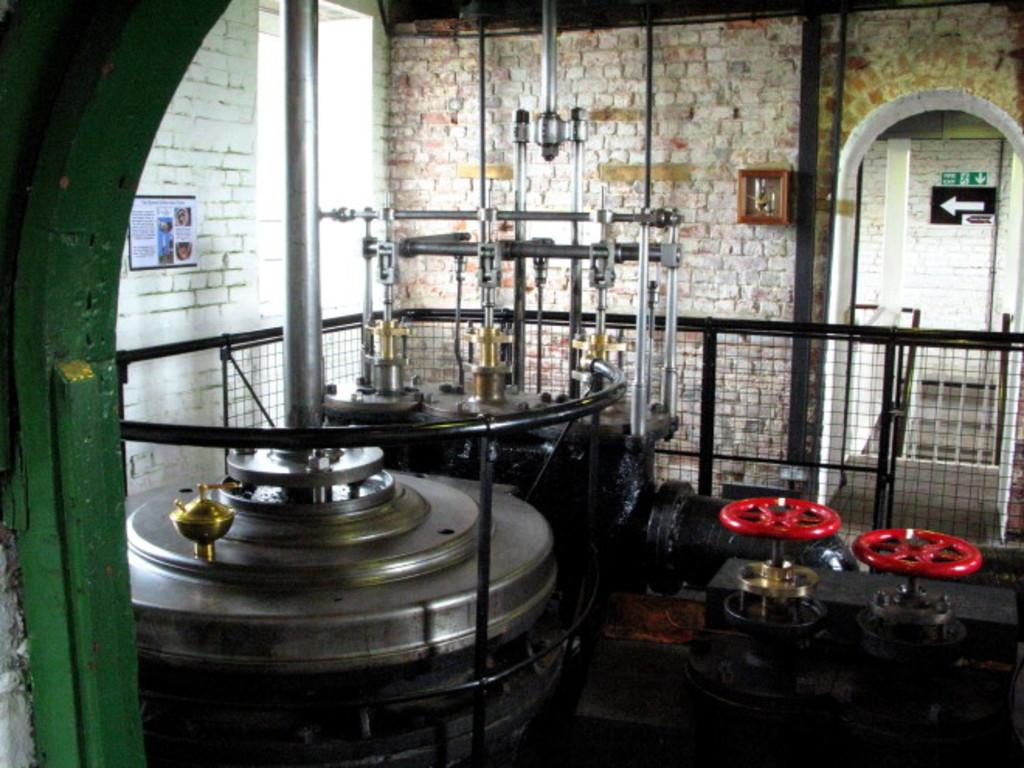What type of objects with metal poles and wheels can be seen in the image? There are machines with metal poles and wheels in the image. What is the paper used for in the image? The purpose of the paper in the image is not specified, but it is present. Where is the wooden box located in the image? The wooden box is on a wall in the image. What type of barrier is present in the image? There is a metal fence in the image. What type of information might be conveyed by the sign boards in the image? The sign boards in the image might convey information such as directions, warnings, or advertisements. What type of coast can be seen in the image? There is no coast present in the image; it features machines, a wooden box, a metal fence, and sign boards. How much heat is being generated by the machines in the image? The amount of heat generated by the machines in the image is not visible or measurable from the image itself. 